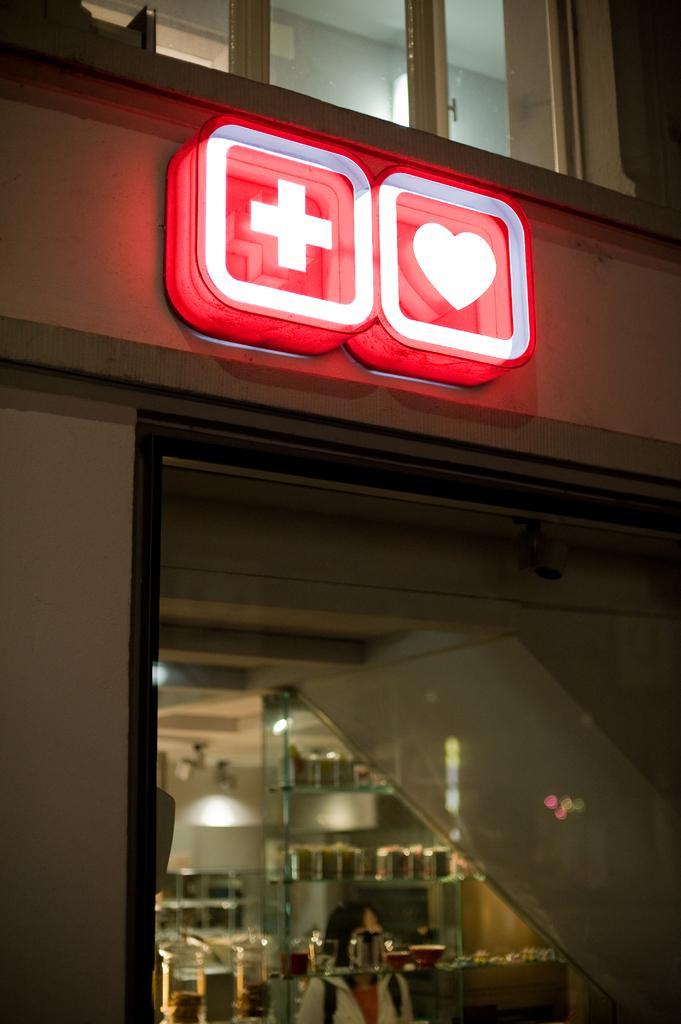Describe this image in one or two sentences. There is a building with windows and sign boards. Inside the building there are many items. 